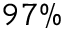Convert formula to latex. <formula><loc_0><loc_0><loc_500><loc_500>9 7 \%</formula> 